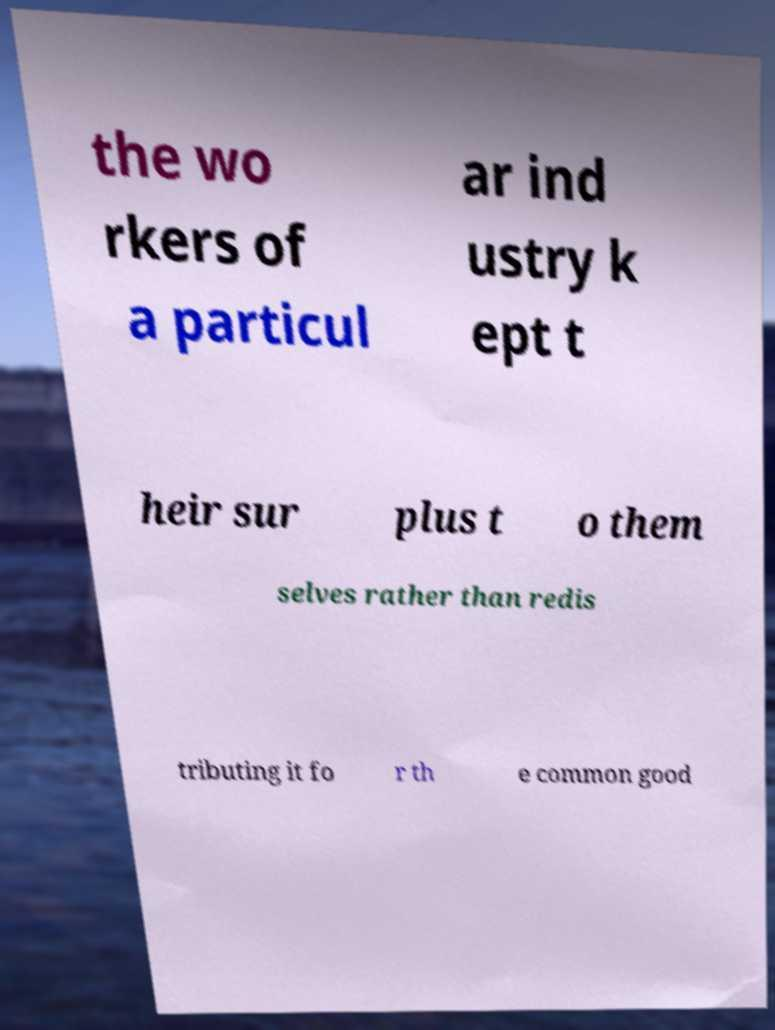What messages or text are displayed in this image? I need them in a readable, typed format. the wo rkers of a particul ar ind ustry k ept t heir sur plus t o them selves rather than redis tributing it fo r th e common good 